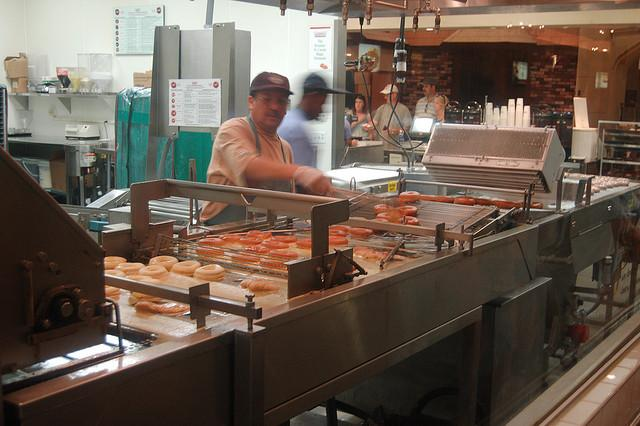What are the people in the background doing? Please explain your reasoning. buy donuts. The people in the background are standing on the opposite side of a counter from the visible register which is the place a customer would stand. there appears to be donuts cooking in the foreground so the people making purchases are likely buying donuts. 